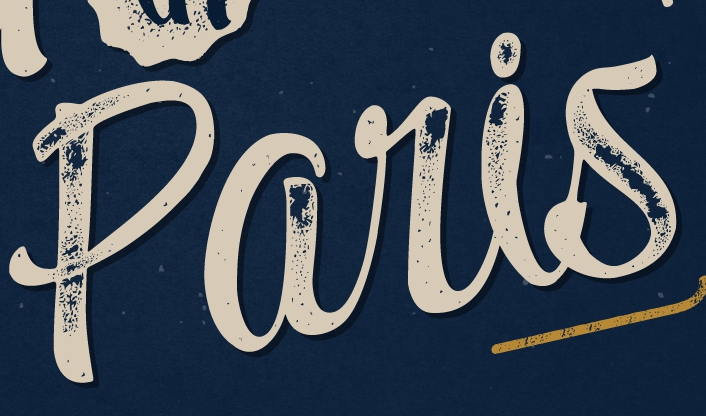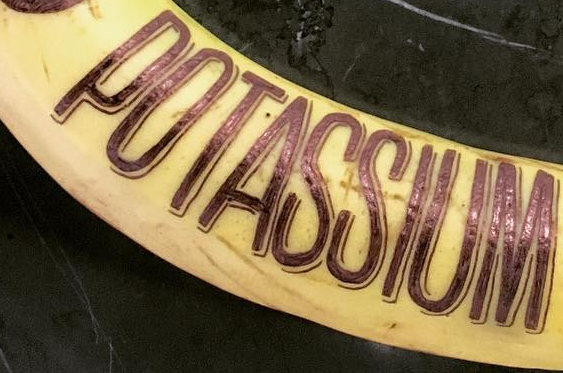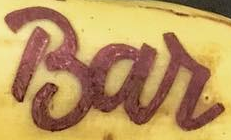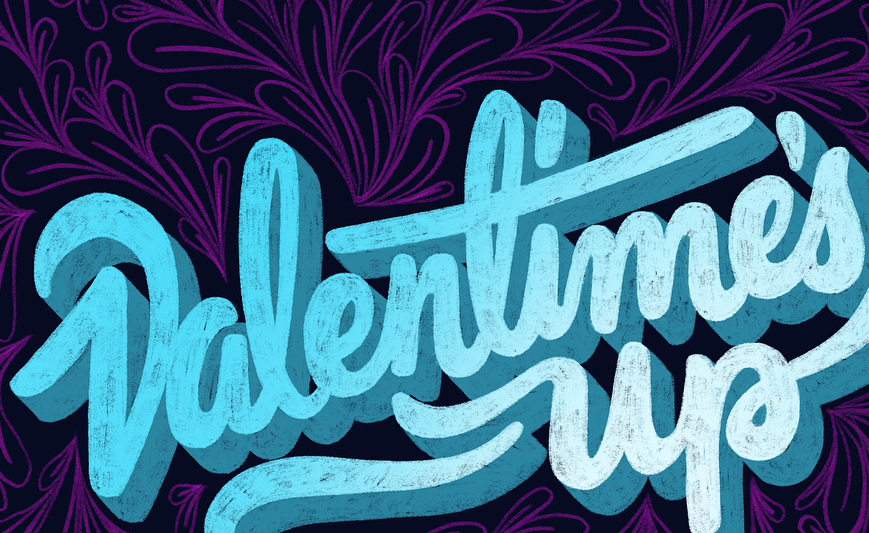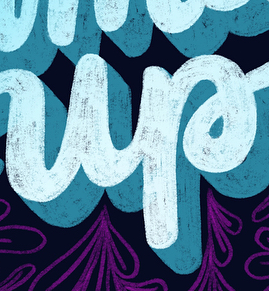Transcribe the words shown in these images in order, separated by a semicolon. paris; POTASSIUM; Bar; Valentime's; up 